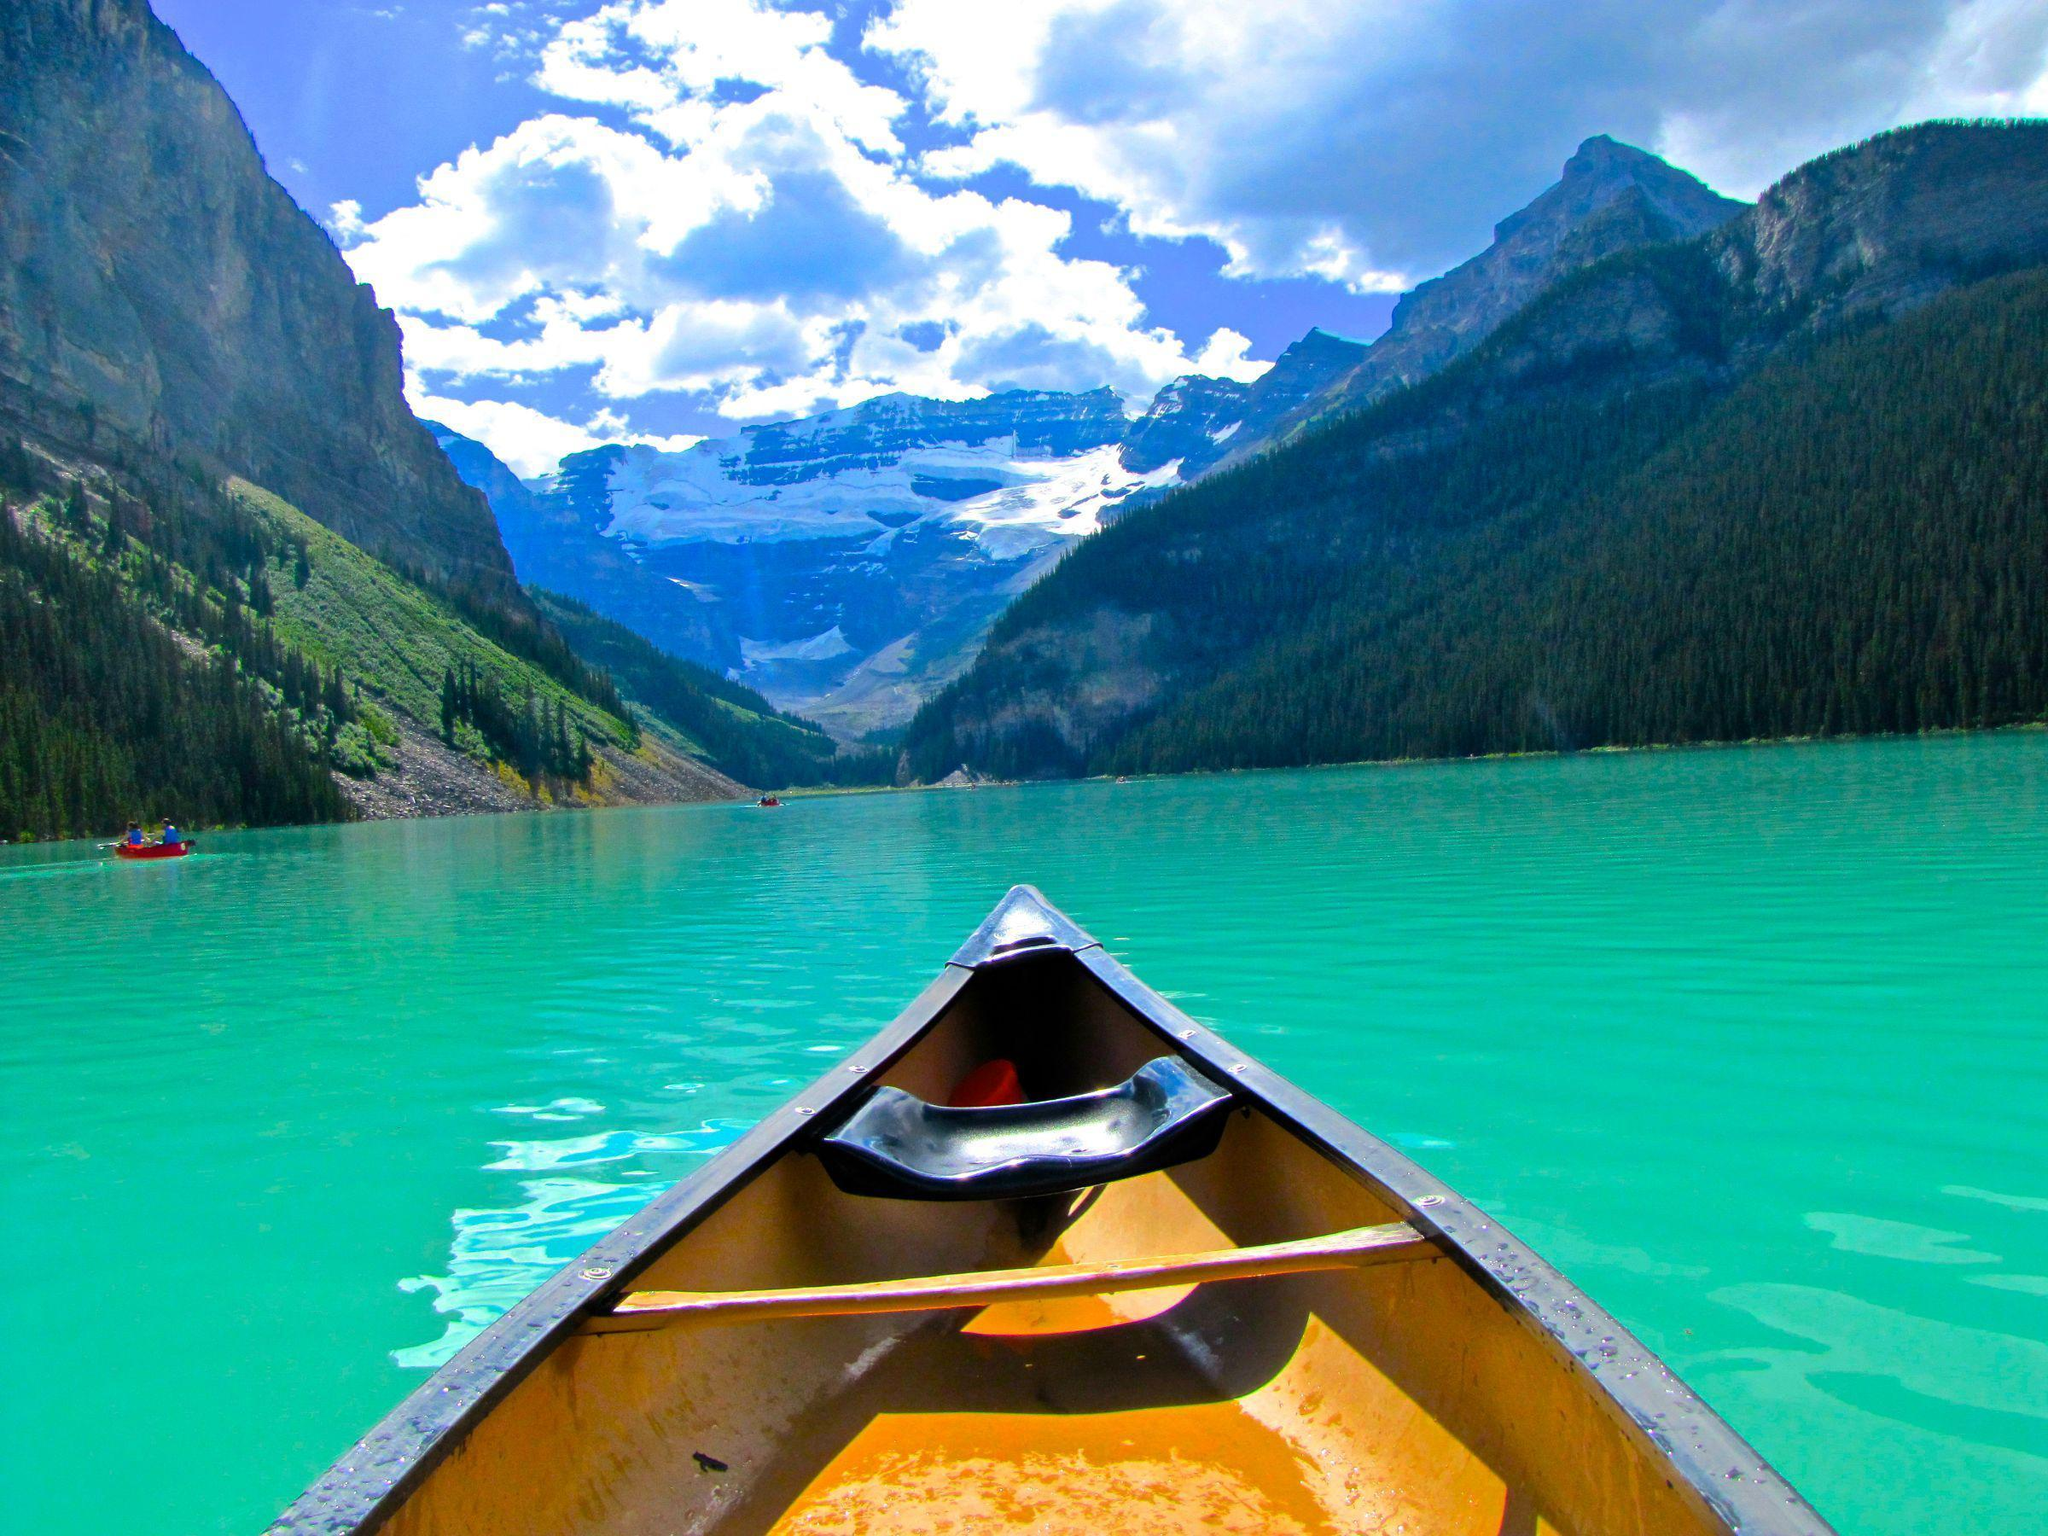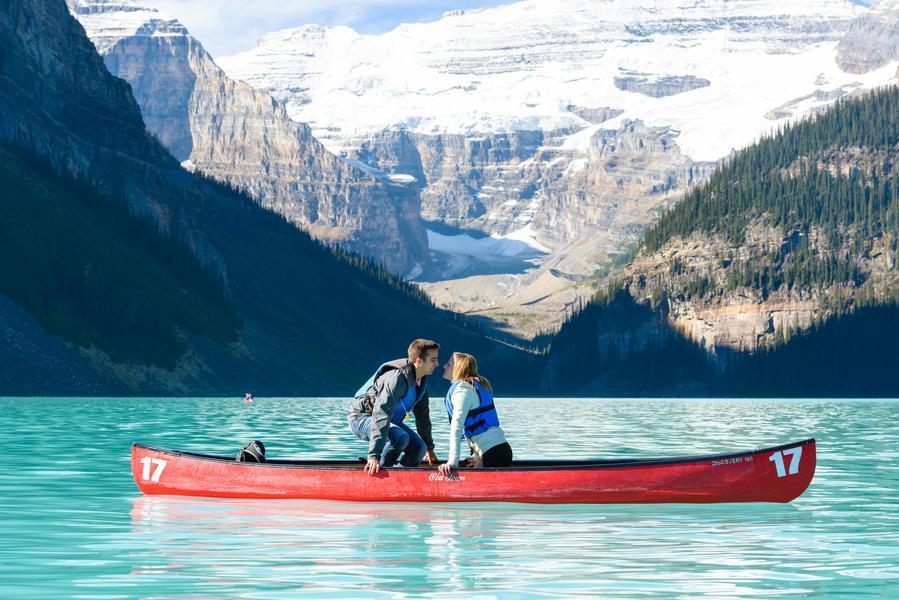The first image is the image on the left, the second image is the image on the right. Considering the images on both sides, is "There is only one red canoe." valid? Answer yes or no. Yes. The first image is the image on the left, the second image is the image on the right. Considering the images on both sides, is "In one image there is a red boat with two people and the other image is a empty boat floating on the water." valid? Answer yes or no. Yes. 